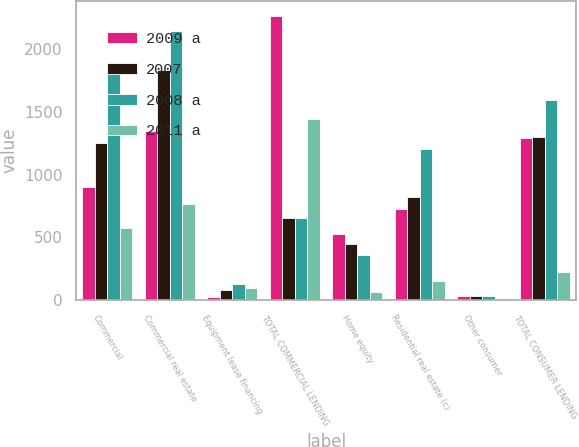Convert chart to OTSL. <chart><loc_0><loc_0><loc_500><loc_500><stacked_bar_chart><ecel><fcel>Commercial<fcel>Commercial real estate<fcel>Equipment lease financing<fcel>TOTAL COMMERCIAL LENDING<fcel>Home equity<fcel>Residential real estate (c)<fcel>Other consumer<fcel>TOTAL CONSUMER LENDING<nl><fcel>2009 a<fcel>899<fcel>1345<fcel>22<fcel>2266<fcel>529<fcel>726<fcel>31<fcel>1294<nl><fcel>2007<fcel>1253<fcel>1835<fcel>77<fcel>651<fcel>448<fcel>818<fcel>35<fcel>1301<nl><fcel>2008 a<fcel>1806<fcel>2140<fcel>130<fcel>651<fcel>356<fcel>1203<fcel>36<fcel>1595<nl><fcel>2011 a<fcel>576<fcel>766<fcel>97<fcel>1439<fcel>66<fcel>153<fcel>4<fcel>223<nl></chart> 